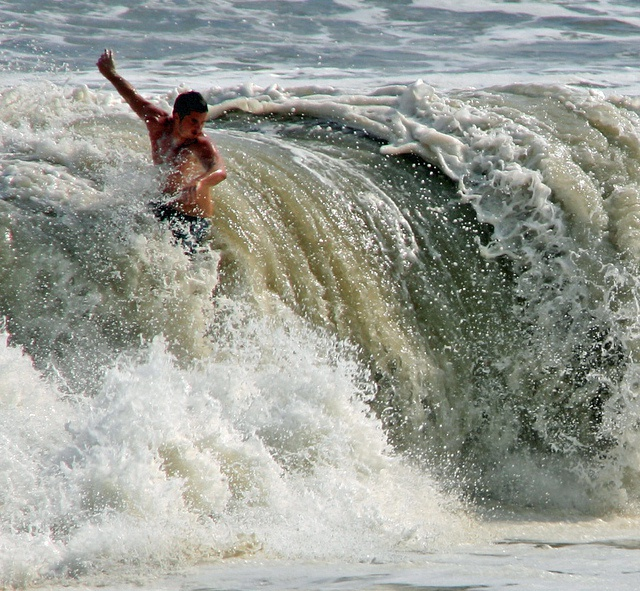Describe the objects in this image and their specific colors. I can see people in darkgray, black, maroon, and gray tones in this image. 